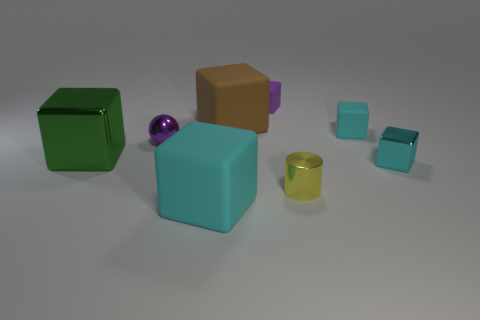Subtract all purple cylinders. How many cyan blocks are left? 3 Subtract all small cyan matte cubes. How many cubes are left? 5 Subtract 2 cubes. How many cubes are left? 4 Subtract all cyan blocks. How many blocks are left? 3 Subtract all purple blocks. Subtract all red cylinders. How many blocks are left? 5 Add 2 tiny matte cubes. How many objects exist? 10 Subtract all blocks. How many objects are left? 2 Subtract 0 gray spheres. How many objects are left? 8 Subtract all small purple shiny balls. Subtract all large brown objects. How many objects are left? 6 Add 4 large green metallic things. How many large green metallic things are left? 5 